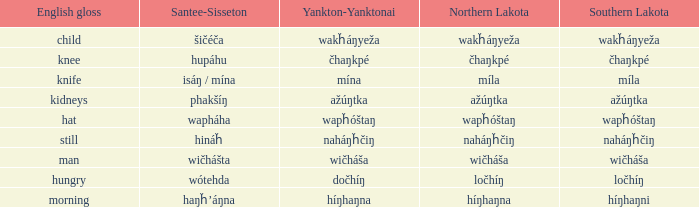Name the santee sisseton for wičháša Wičhášta. Parse the full table. {'header': ['English gloss', 'Santee-Sisseton', 'Yankton-Yanktonai', 'Northern Lakota', 'Southern Lakota'], 'rows': [['child', 'šičéča', 'wakȟáŋyeža', 'wakȟáŋyeža', 'wakȟáŋyeža'], ['knee', 'hupáhu', 'čhaŋkpé', 'čhaŋkpé', 'čhaŋkpé'], ['knife', 'isáŋ / mína', 'mína', 'míla', 'míla'], ['kidneys', 'phakšíŋ', 'ažúŋtka', 'ažúŋtka', 'ažúŋtka'], ['hat', 'wapháha', 'wapȟóštaŋ', 'wapȟóštaŋ', 'wapȟóštaŋ'], ['still', 'hináȟ', 'naháŋȟčiŋ', 'naháŋȟčiŋ', 'naháŋȟčiŋ'], ['man', 'wičhášta', 'wičháša', 'wičháša', 'wičháša'], ['hungry', 'wótehda', 'dočhíŋ', 'ločhíŋ', 'ločhíŋ'], ['morning', 'haŋȟ’áŋna', 'híŋhaŋna', 'híŋhaŋna', 'híŋhaŋni']]} 